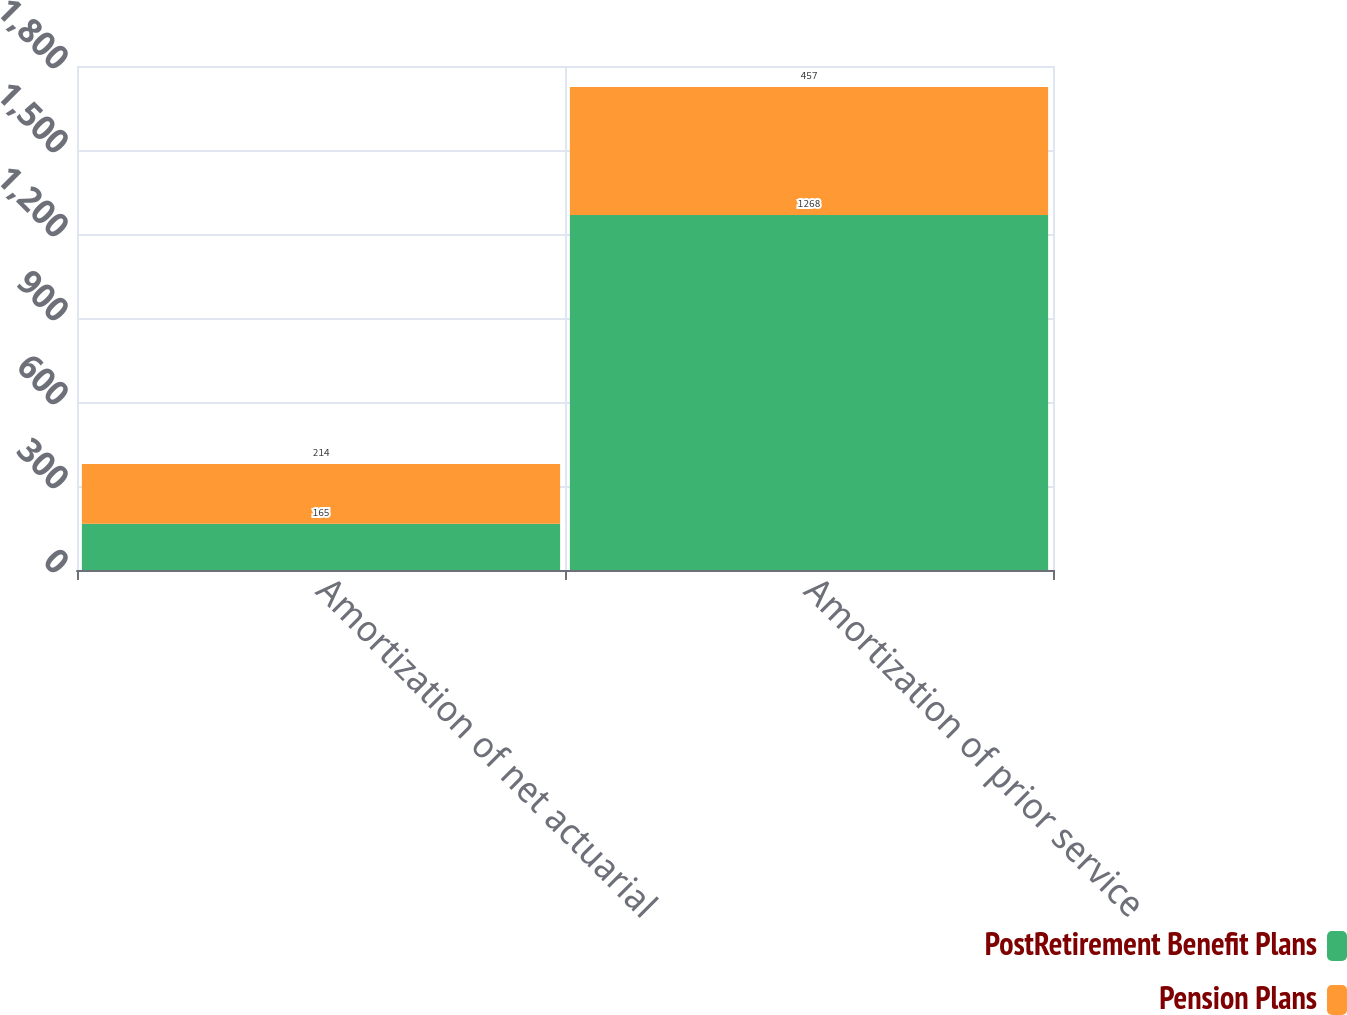<chart> <loc_0><loc_0><loc_500><loc_500><stacked_bar_chart><ecel><fcel>Amortization of net actuarial<fcel>Amortization of prior service<nl><fcel>PostRetirement Benefit Plans<fcel>165<fcel>1268<nl><fcel>Pension Plans<fcel>214<fcel>457<nl></chart> 